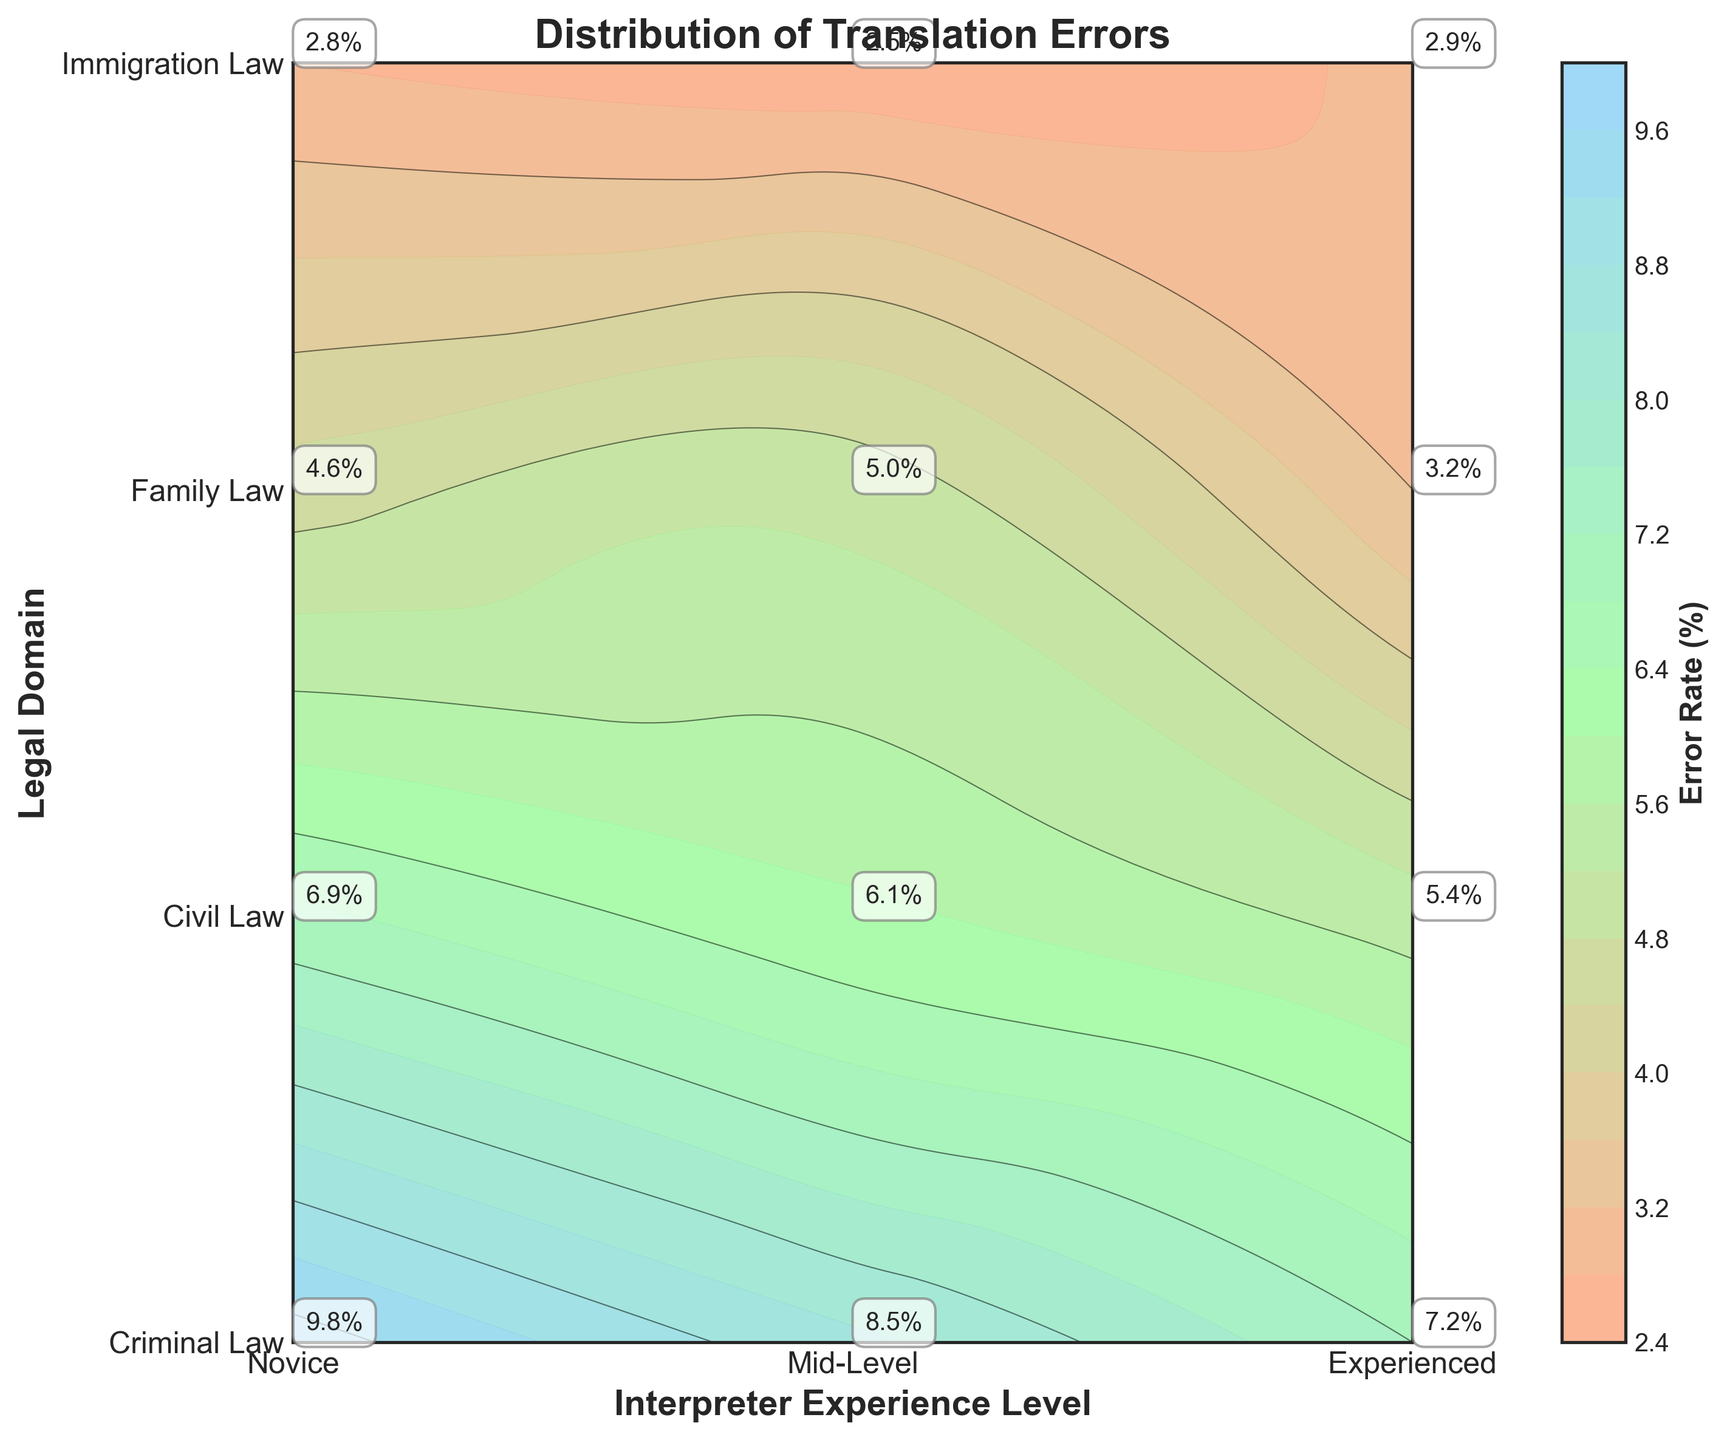What is the title of the plot? The title is displayed prominently at the top of the plot. It usually provides a brief description of what the plot is about. Here, the title reads 'Distribution of Translation Errors'.
Answer: Distribution of Translation Errors What do the x-axis and y-axis represent? The labels on the x-axis and y-axis describe what each axis represents. The x-axis represents 'Interpreter Experience Level', and the y-axis represents 'Legal Domain'.
Answer: Interpreter Experience Level, Legal Domain Which interpreter experience level has the lowest error rate in Criminal Law? From the contour plot, the lowest error rate for Criminal Law can be found at the point where the x-axis (Interpreter Experience Level) is 'Experienced'. A specific annotation at this point shows an error rate of 3.2%.
Answer: Experienced In which legal domain do Novice interpreters make the most errors? By observing the annotated error rates on the plot for Novice interpreters (x=0), we find the highest error in 'Criminal Law', marked with an error rate of 9.8%.
Answer: Criminal Law Compare the error rates between Novice and Experienced interpreters in Immigration Law. Which group has a higher error rate, and by how much? The error rate for Novice interpreters in Immigration Law is 6.9%, and for Experienced interpreters, it's 2.9%. The difference is calculated as \(6.9\% - 2.9\% = 4\%\).
Answer: Novice, 4% What's the average error rate for Mid-Level interpreters across all legal domains? Mid-Level error rates are: Criminal Law (6.1%), Civil Law (5.4%), Family Law (4.6%), Immigration Law (5.0%). The average is \(\frac{6.1 + 5.4 + 4.6 + 5.0}{4} = 5.275\%\).
Answer: 5.275% Which legal domain shows the highest variance in error rates across different interpreter experience levels? By comparing the annotated error rates in each legal domain: Criminal Law (9.8%, 6.1%, 3.2%), Civil Law (8.5%, 5.4%, 2.8%), Family Law (7.2%, 4.6%, 2.5%), and Immigration Law (6.9%, 5.0%, 2.9%), Criminal Law has the largest range \(9.8\% - 3.2\% = 6.6\%\).
Answer: Criminal Law How does the error rate trend change with increasing interpreter experience in Family Law? Observing the annotated values for Family Law (y-axis value 2), the error rates decrease from Novice (7.2%), Mid-Level (4.6%), to Experienced (2.5%). This shows a downward trend.
Answer: Decreases Which color predominates in areas with the lowest error rates on the plot? The color gradient on the plot indicates that lower error rates are represented by cooler colors. Light blue is seen in regions with the lowest error rates.
Answer: Light blue 